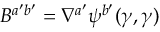Convert formula to latex. <formula><loc_0><loc_0><loc_500><loc_500>B ^ { a ^ { \prime } b ^ { \prime } } = \nabla ^ { a ^ { \prime } } \psi ^ { b ^ { \prime } } ( \gamma , \gamma )</formula> 